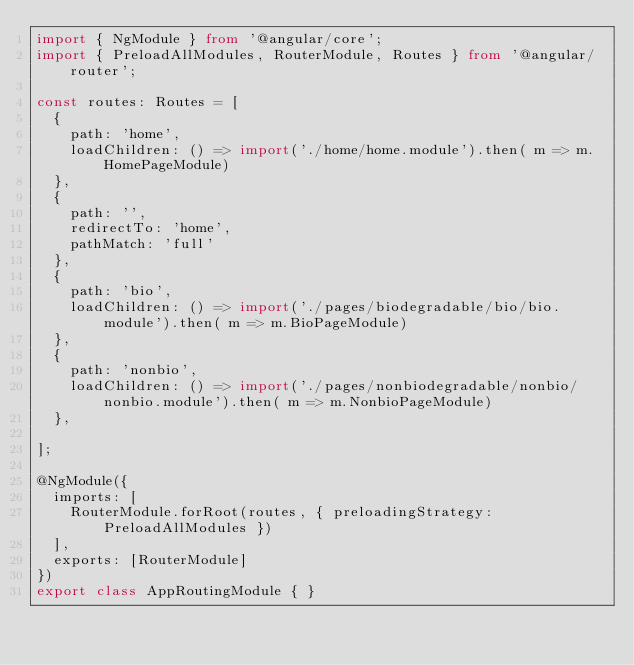<code> <loc_0><loc_0><loc_500><loc_500><_TypeScript_>import { NgModule } from '@angular/core';
import { PreloadAllModules, RouterModule, Routes } from '@angular/router';

const routes: Routes = [
  {
    path: 'home',
    loadChildren: () => import('./home/home.module').then( m => m.HomePageModule)
  },
  {
    path: '',
    redirectTo: 'home',
    pathMatch: 'full'
  },
  {
    path: 'bio',
    loadChildren: () => import('./pages/biodegradable/bio/bio.module').then( m => m.BioPageModule)
  },
  {
    path: 'nonbio',
    loadChildren: () => import('./pages/nonbiodegradable/nonbio/nonbio.module').then( m => m.NonbioPageModule)
  },

];

@NgModule({
  imports: [
    RouterModule.forRoot(routes, { preloadingStrategy: PreloadAllModules })
  ],
  exports: [RouterModule]
})
export class AppRoutingModule { }
</code> 